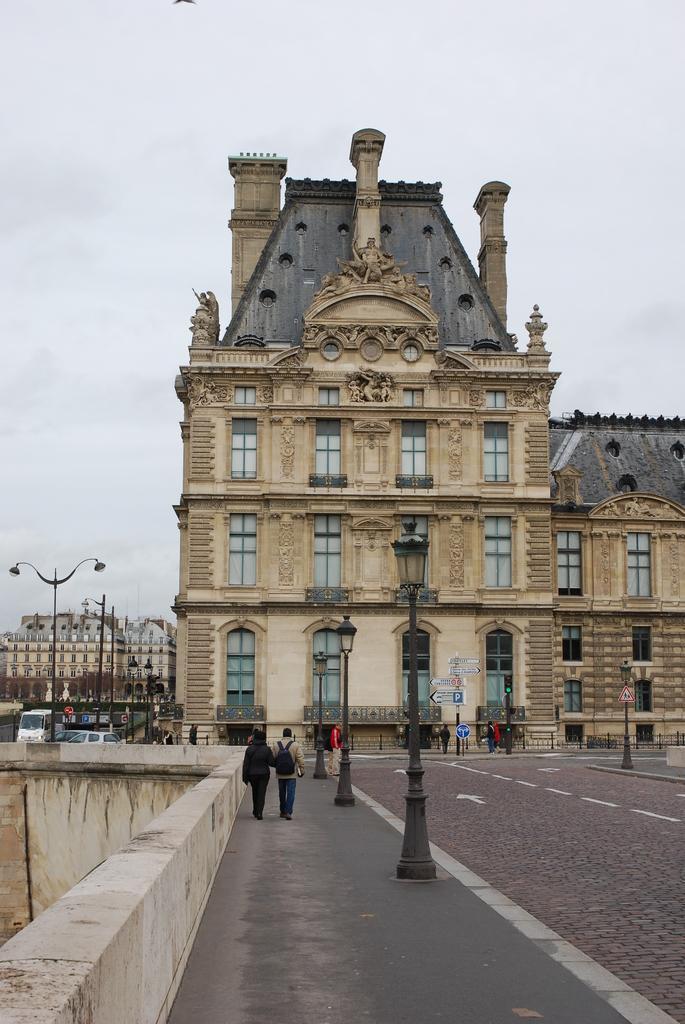Describe this image in one or two sentences. This picture shows buildings and we see vehicles and few pole lights & sign boards and we see people walking on the sidewalk and few are standing and we see a man wore backpack on his back and we see a cloudy Sky. 